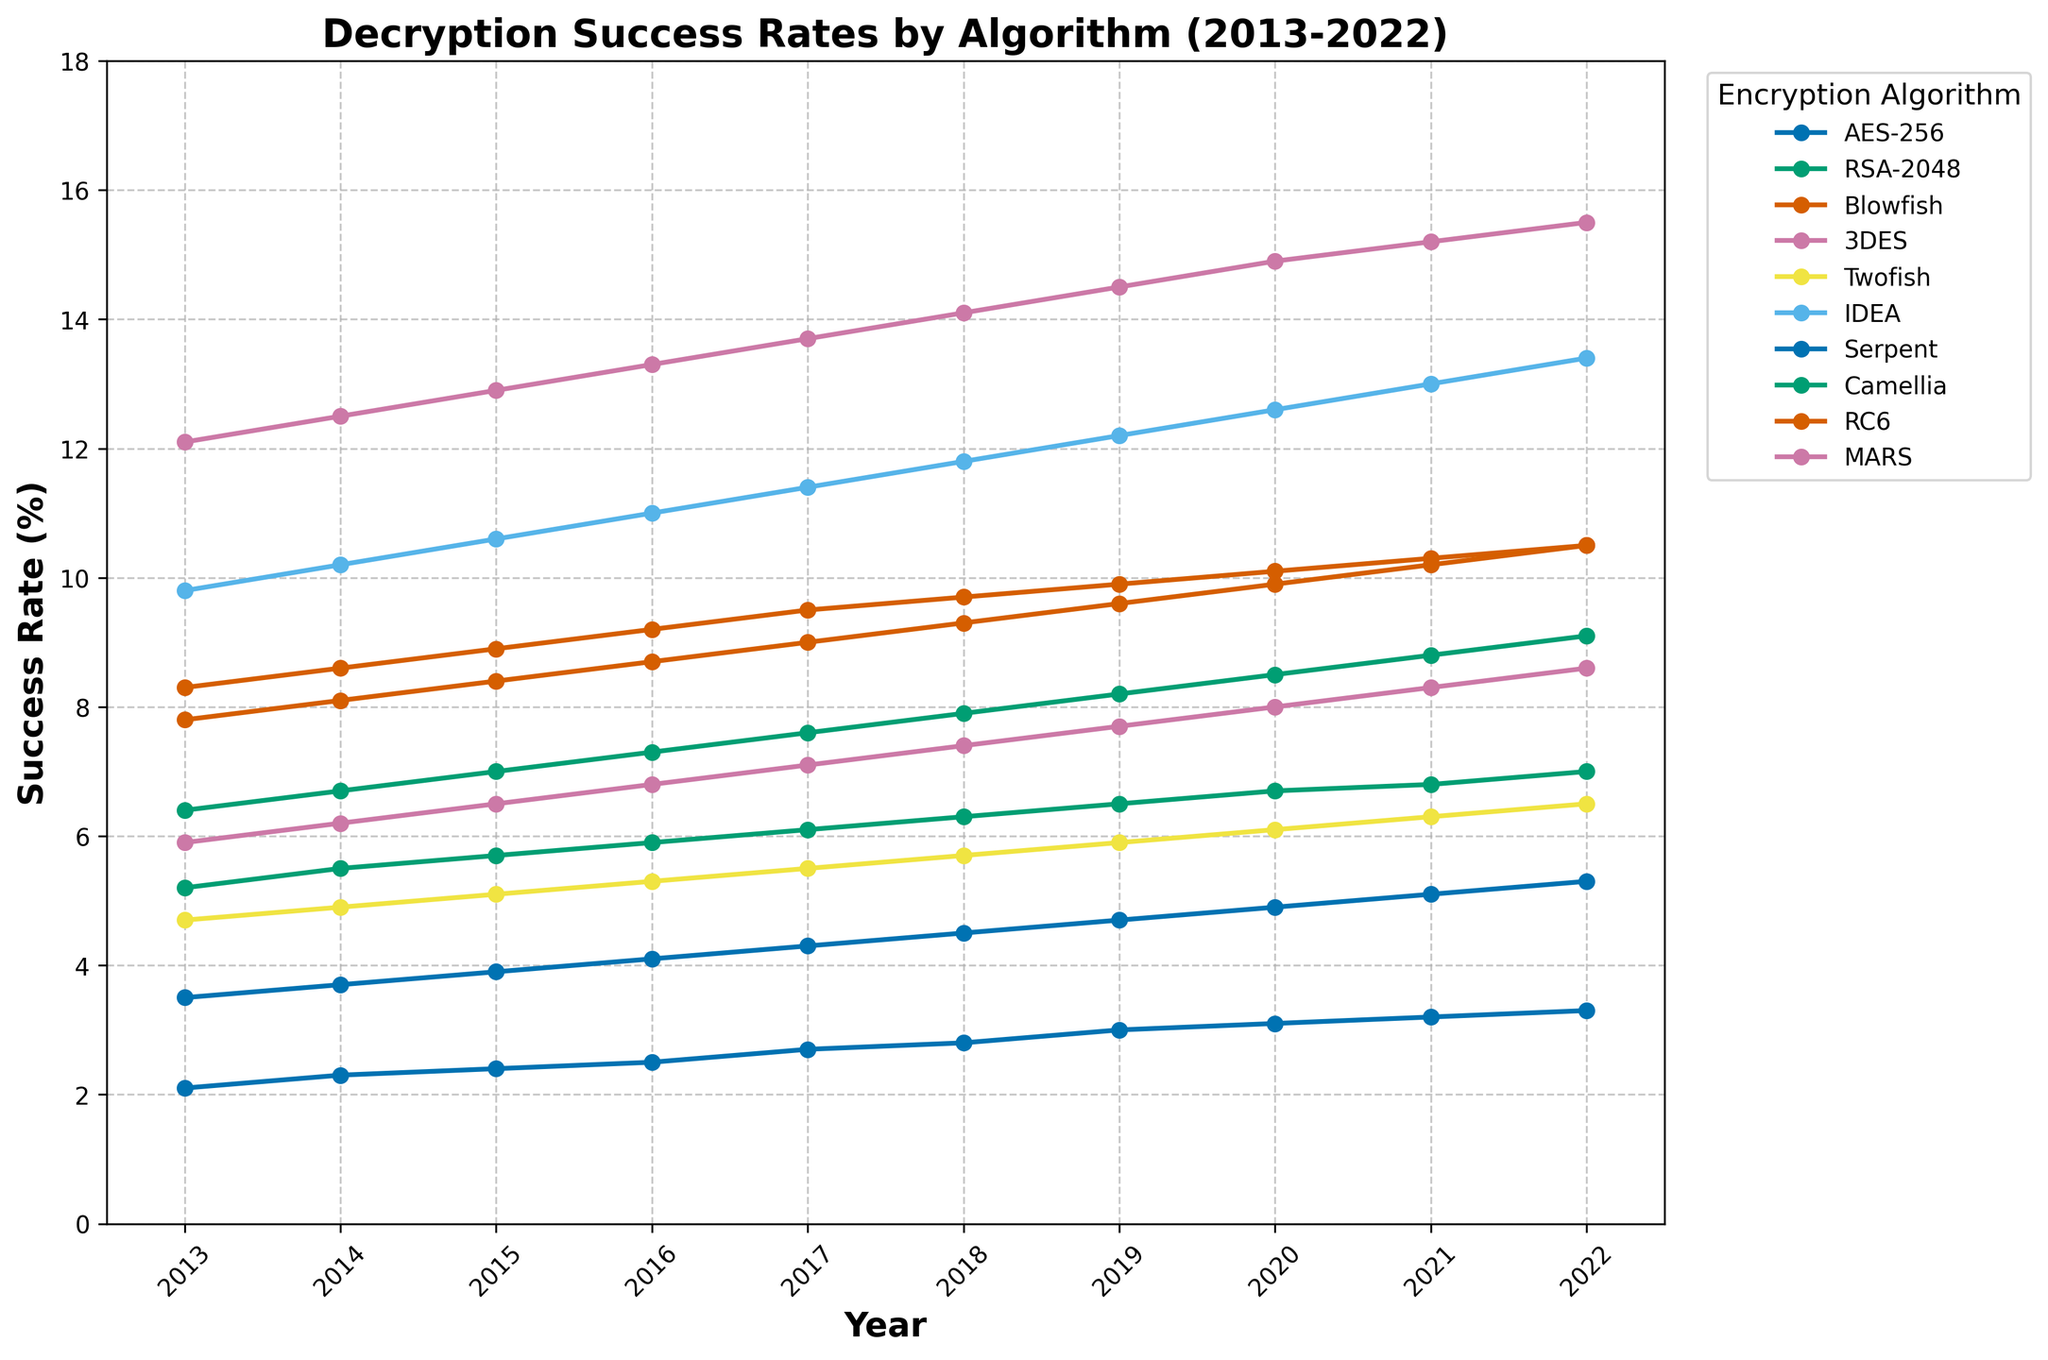What is the trend for AES-256 from 2013 to 2022? The line for AES-256 shows a consistent increase in success rates from 2.1% in 2013 to 3.3% in 2022. This suggests that the success rate of decryption for AES-256 has steadily increased over the decade.
Answer: Increasing Which algorithm had the highest success rate in decryption in 2020? To find this, look at the values for each algorithm in the year 2020. The highest value is for 3DES with a success rate of 14.9%.
Answer: 3DES Compare the success rates of Blowfish and RSA-2048 in 2019. Which one is higher and by how much? In 2019, Blowfish had a success rate of 9.9%, while RSA-2048 had a rate of 6.5%. The difference between the two is 9.9% - 6.5% = 3.4%, with Blowfish being higher.
Answer: Blowfish by 3.4% What is the average success rate for MARS over the 10-year period? Add the success rates for MARS from 2013 to 2022: (5.9 + 6.2 + 6.5 + 6.8 + 7.1 + 7.4 + 7.7 + 8.0 + 8.3 + 8.6)/10 = 7.25%.
Answer: 7.25% Which algorithm shows the greatest overall increase in success rates from 2013 to 2022? To find this, subtract the 2013 success rate from the 2022 success rate for each algorithm. The greatest increase is for IDEA, which went from 9.8% in 2013 to 13.4% in 2022, an increase of 3.6%.
Answer: IDEA Compare the success rates between Serpent and Camellia in 2017. Which one is lower and by how much? In 2017, Serpent had a success rate of 4.3%, and Camellia had 7.6%. The difference is 7.6% - 4.3% = 3.3%, with Serpent being lower.
Answer: Serpent by 3.3% In which year did RC6 reach a success rate of 10.5%? Look at the values for RC6 and find the year corresponding to 10.5%, which is 2022.
Answer: 2022 How do the rates of increase for 3DES and Twofish compare over the entire 10-year period? Calculate the increase for both from 2013 to 2022: 3DES increases from 12.1 to 15.5, a change of 3.4, and Twofish increases from 4.7 to 6.5, a change of 1.8. Thus, 3DES has a larger increase over the period.
Answer: 3DES has a larger increase Which algorithm had the slowest increase in success rate over the years, and what is this increase? By comparing the changes from 2013 to 2022, AES-256 had the slowest increase, going from 2.1% to 3.3%, an increase of 1.2%.
Answer: AES-256 by 1.2% Compare the visual representation of the trend lines for AES-256 and Blowfish. Describe the primary difference in terms of their slopes. The AES-256 trend line has a gentle, steady slope indicating a slow but consistent increase, whereas the Blowfish trend line has a steeper slope, indicating a faster increase in success rate over the years.
Answer: AES-256 is slower, Blowfish is faster 